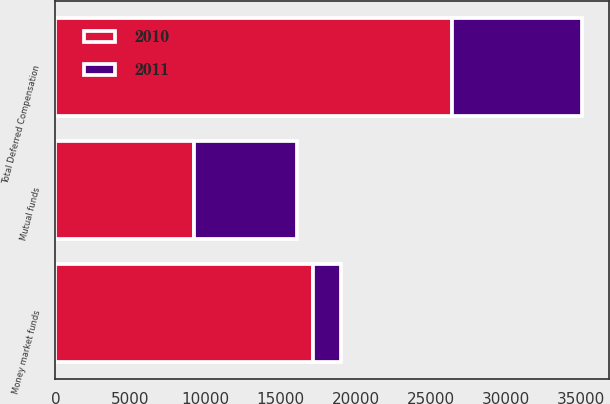<chart> <loc_0><loc_0><loc_500><loc_500><stacked_bar_chart><ecel><fcel>Money market funds<fcel>Mutual funds<fcel>Total Deferred Compensation<nl><fcel>2010<fcel>17187<fcel>9223<fcel>26410<nl><fcel>2011<fcel>1840<fcel>6850<fcel>8690<nl></chart> 